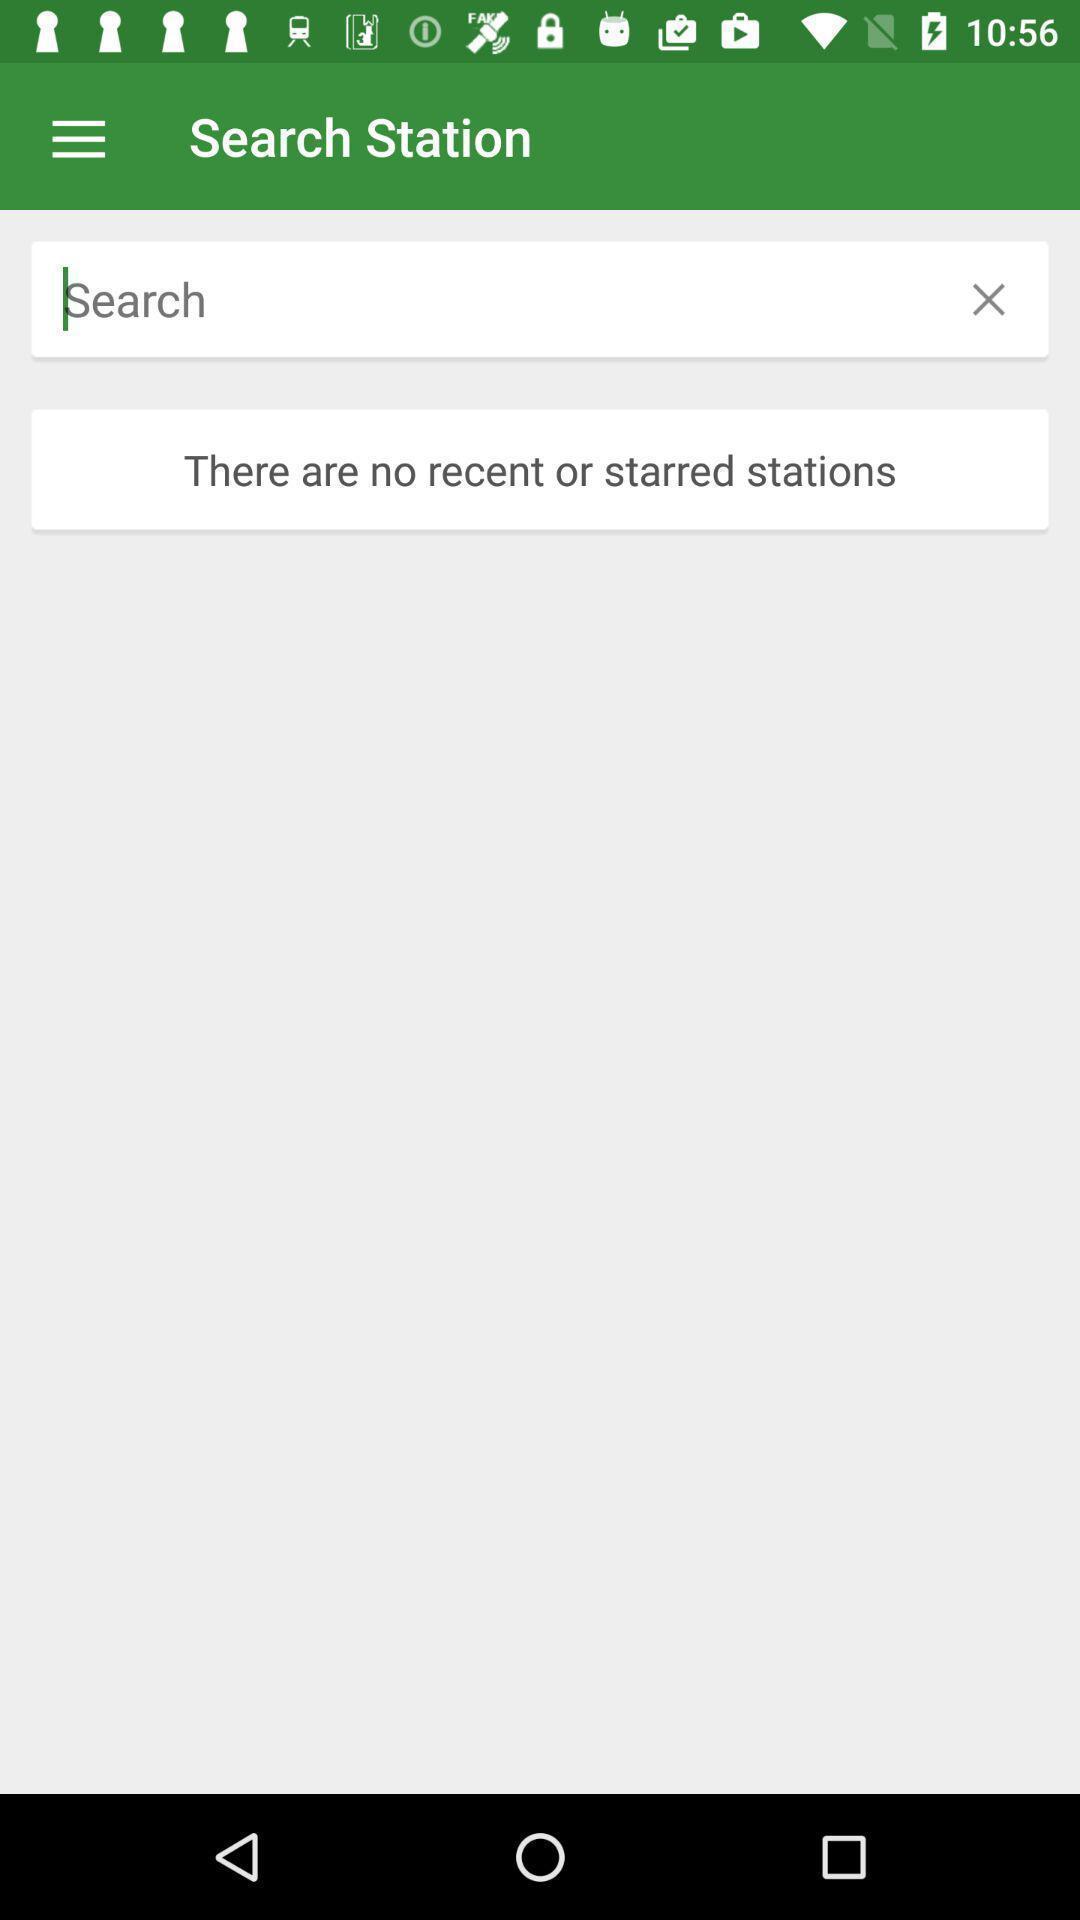Summarize the information in this screenshot. Search page displayed of an train application. 